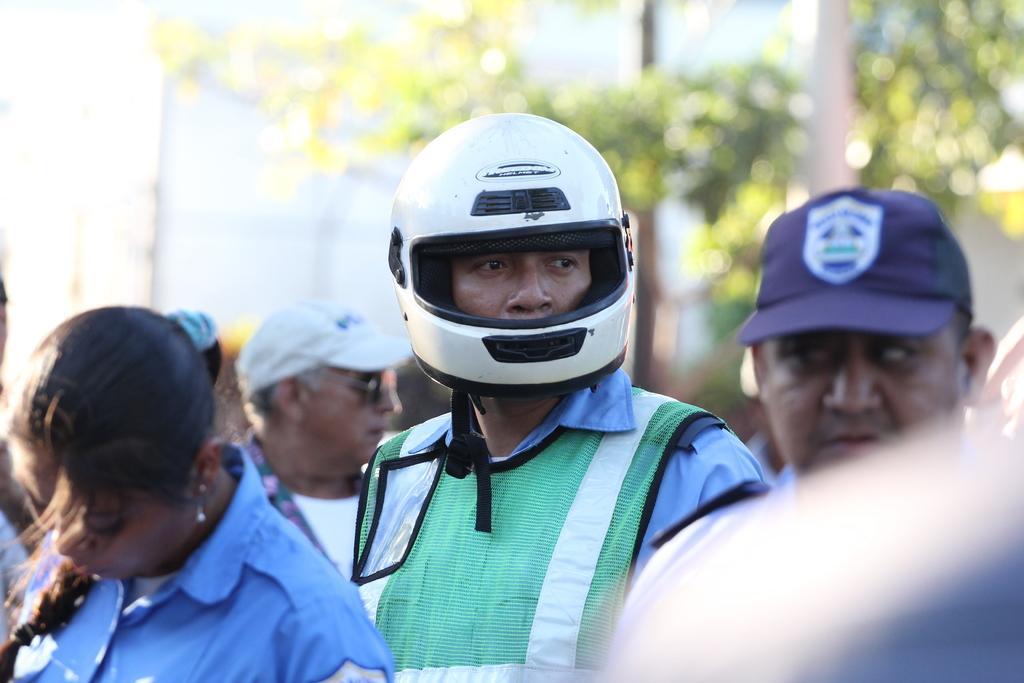Describe this image in one or two sentences. As we can see in the image there are few people here and there and in the background there are trees. The man standing over here is wearing a helmet. 